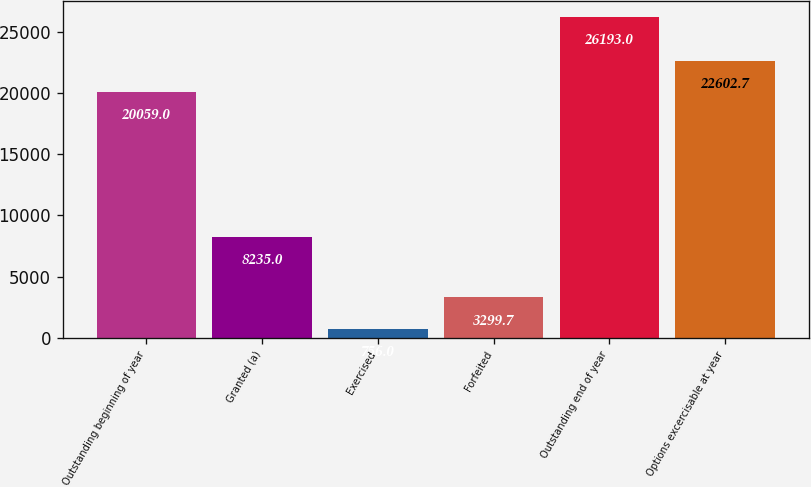Convert chart to OTSL. <chart><loc_0><loc_0><loc_500><loc_500><bar_chart><fcel>Outstanding beginning of year<fcel>Granted (a)<fcel>Exercised<fcel>Forfeited<fcel>Outstanding end of year<fcel>Options excercisable at year<nl><fcel>20059<fcel>8235<fcel>756<fcel>3299.7<fcel>26193<fcel>22602.7<nl></chart> 